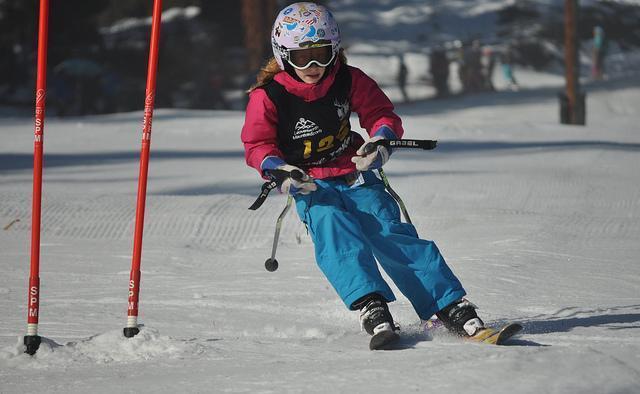How many elephants are on the right page?
Give a very brief answer. 0. 